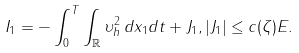Convert formula to latex. <formula><loc_0><loc_0><loc_500><loc_500>I _ { 1 } = - \int _ { 0 } ^ { T } \int _ { \mathbb { R } } \upsilon _ { h } ^ { 2 } \, d x _ { 1 } d t + J _ { 1 } , | J _ { 1 } | \leq c ( \zeta ) E .</formula> 